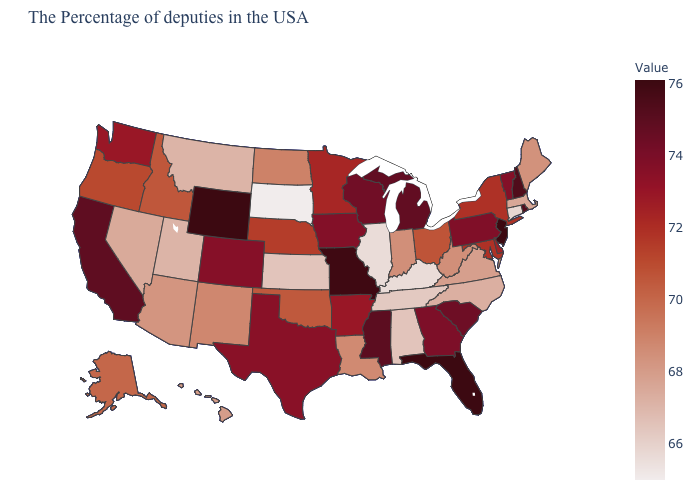Is the legend a continuous bar?
Quick response, please. Yes. Among the states that border Wyoming , which have the highest value?
Write a very short answer. Colorado. 